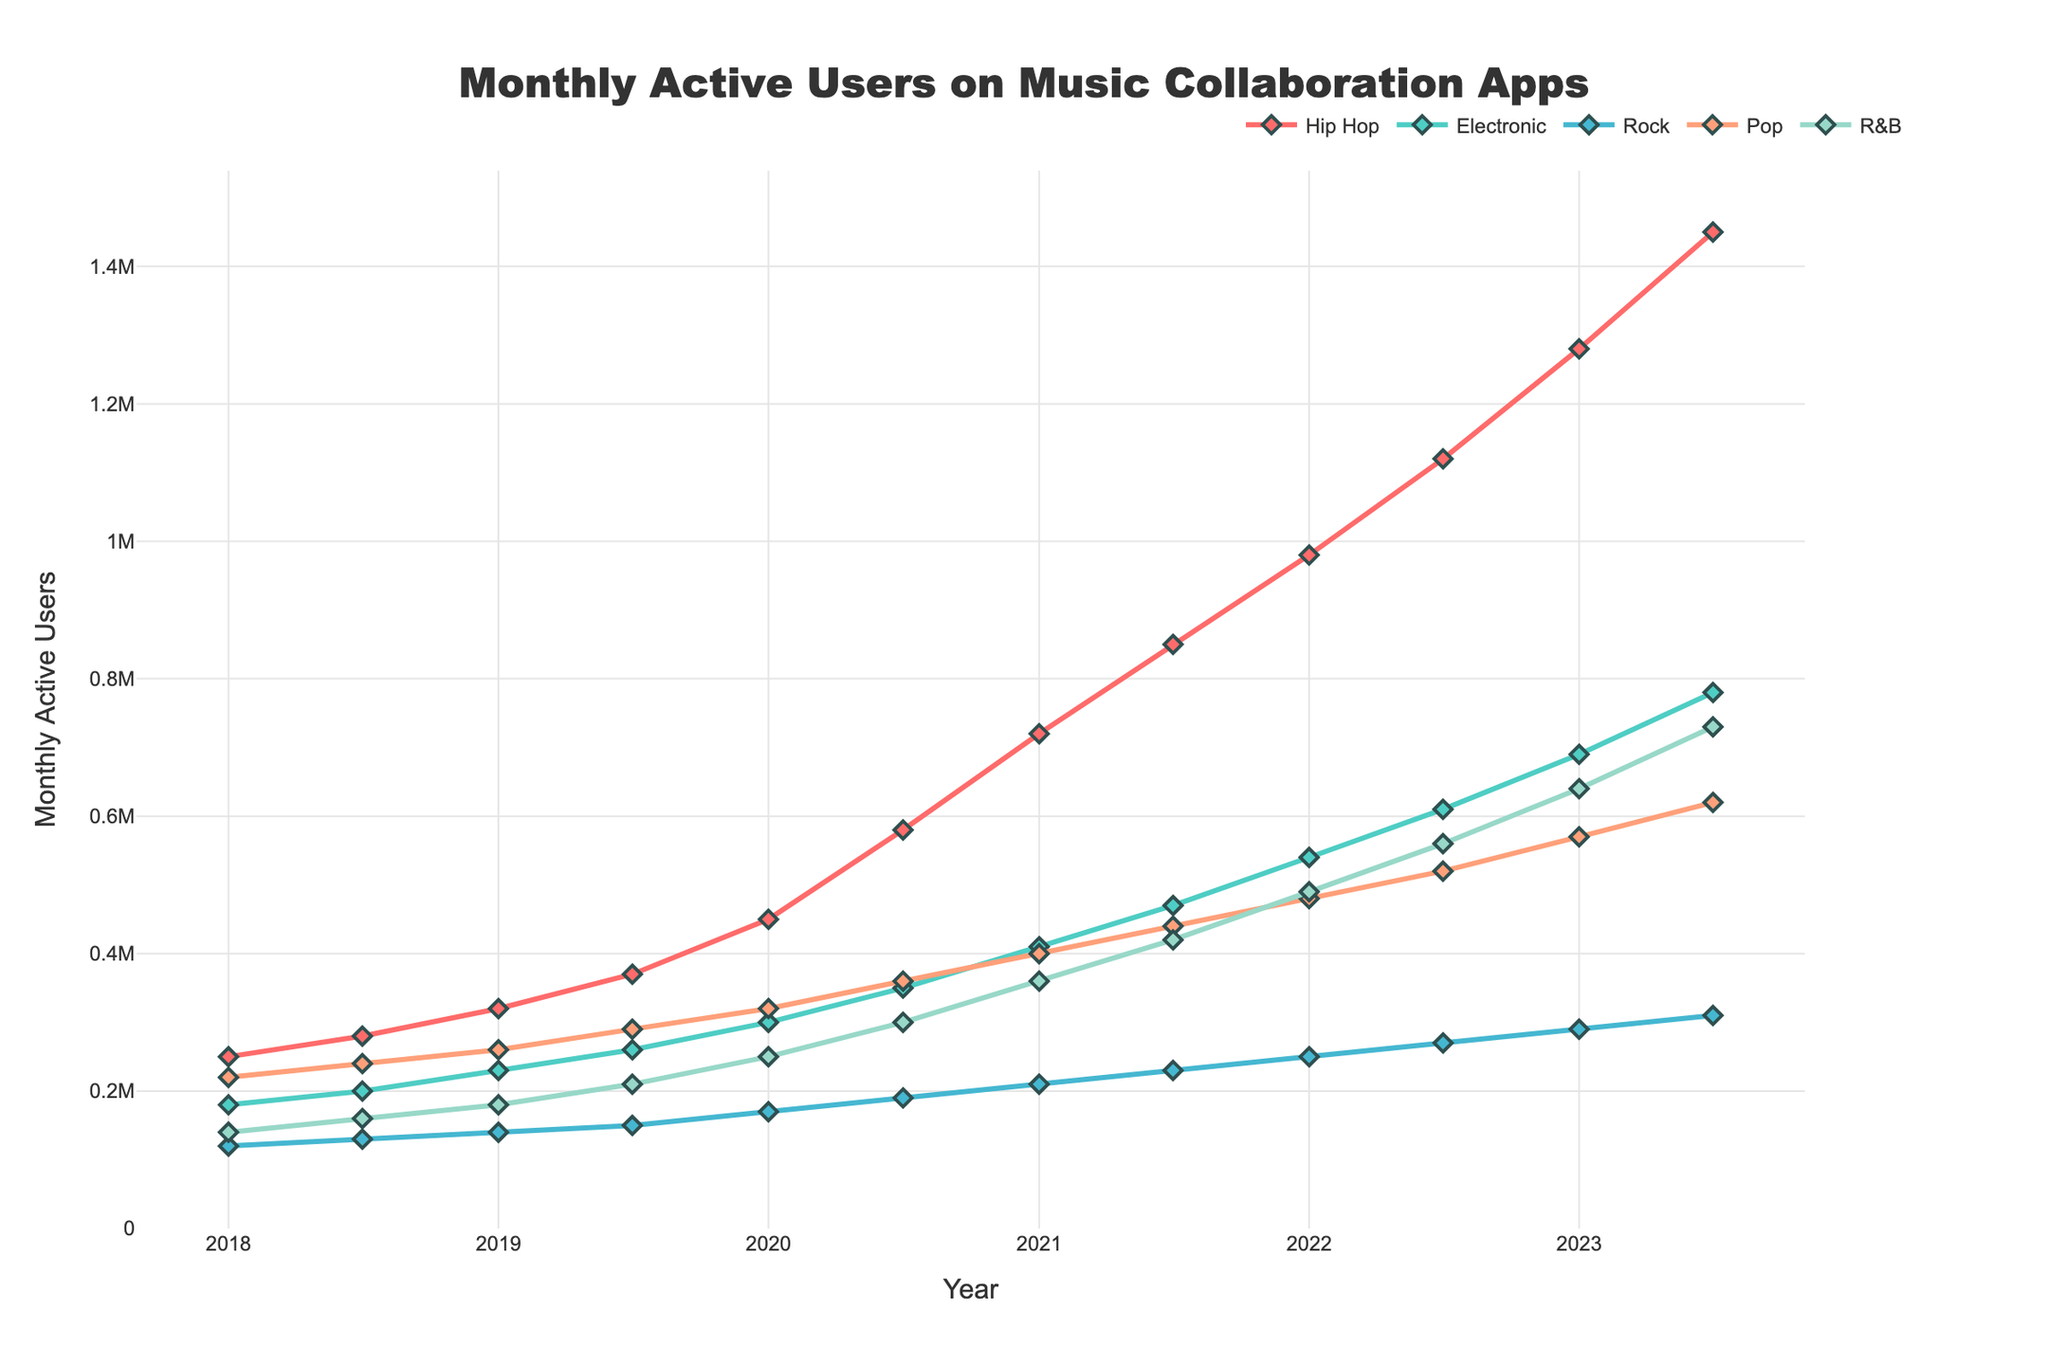which genre has the highest number of users in January 2023? By observing the plot, you can see that the Hip Hop genre line has the highest point among all genres in January 2023.
Answer: Hip Hop compare the increase in users for Hip Hop and Pop from July 2018 to July 2023. For Hip Hop, the increase is 1,450,000 - 280,000 = 1,170,000 users. For Pop, the increase is 620,000 - 240,000 = 380,000 users.
Answer: Hip Hop: 1,170,000, Pop: 380,000 What is the average number of users for R&B in January of each year? The numbers for January are 140,000 (2018), 180,000 (2019), 250,000 (2020), 360,000 (2021), 490,000 (2022), and 640,000 (2023). Sum these values and divide by 6 to find the average: (140,000 + 180,000 + 250,000 + 360,000 + 490,000 + 640,000) / 6 = 343,333.33.
Answer: 343,333.33 Which genre saw the largest percentage increase in users from January 2018 to July 2023? Calculate the percentage increase as ((July 2023 - January 2018) / January 2018) * 100 for each genre. Hip Hop: ((1,450,000 - 250,000) / 250,000) * 100 = 480%. Electronic: ((780,000 - 180,000) / 180,000) * 100 = 333.33%. Rock: ((310,000 - 120,000) / 120,000) * 100 = 158.33%. Pop: ((620,000 - 220,000) / 220,000) * 100 = 181.82%. R&B: ((730,000 - 140,000) / 140,000) * 100 = 421.43%. Hip Hop has the largest increase.
Answer: Hip Hop What is the trend for monthly active users in the Electronic genre over the past 5 years? The plot shows that the number of users in the Electronic genre has been steadily increasing over the past 5 years, starting at 180,000 in January 2018 and ending at 780,000 in July 2023.
Answer: Increasing compare user growth trends for Rock and R&B from January 2018 to July 2023. Visually, both Rock and R&B show growth, but R&B has a steeper incline. Rock increases from 120,000 to 310,000 (up by 190,000), while R&B grows from 140,000 to 730,000 (up by 590,000).
Answer: R&B has a steeper growth trend What is the difference in the number of users between Hip Hop and Rock in July 2023? The number of users for Hip Hop in July 2023 is 1,450,000 and for Rock is 310,000. The difference is 1,450,000 - 310,000 = 1,140,000 users.
Answer: 1,140,000 During which period did Pop experience the most significant growth? Between July 2019 and January 2020, Pop users grew from 290,000 to 320,000. However, the most significant growth occurred between January 2020 (320,000) and July 2020 (360,000), showing a jump of 40,000 users.
Answer: January 2020 to July 2020 Which genre surpassed 1 million users first, and when did it happen? Looking at the plot, Hip Hop surpassed 1 million users first in January 2022.
Answer: Hip Hop, January 2022 